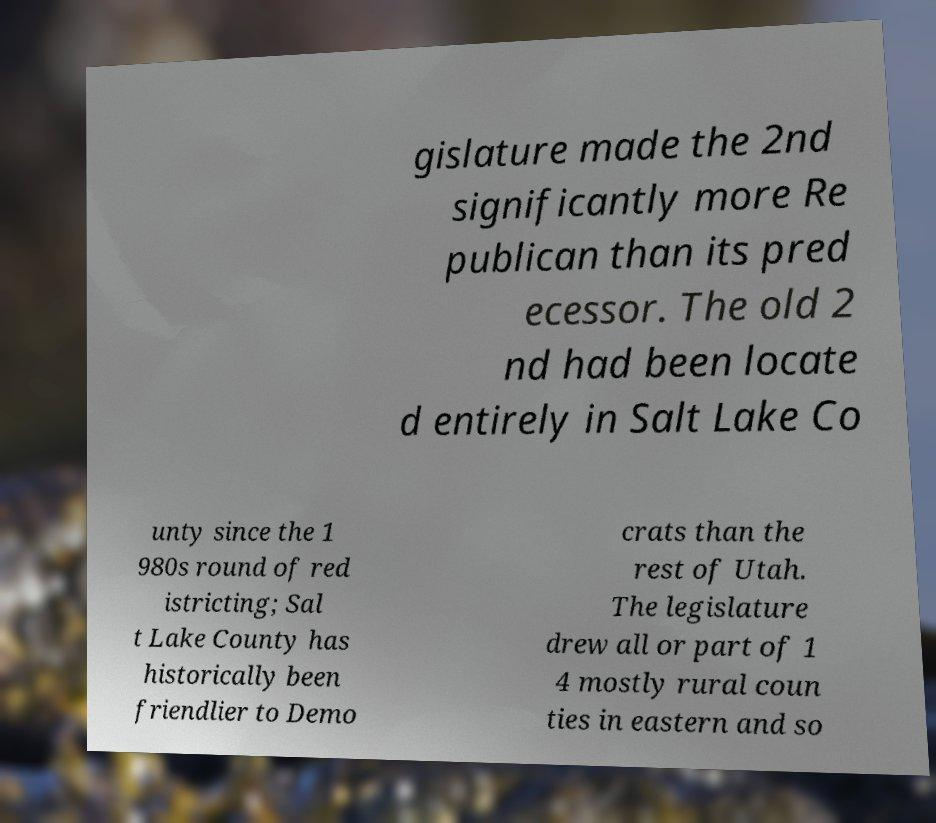Please read and relay the text visible in this image. What does it say? gislature made the 2nd significantly more Re publican than its pred ecessor. The old 2 nd had been locate d entirely in Salt Lake Co unty since the 1 980s round of red istricting; Sal t Lake County has historically been friendlier to Demo crats than the rest of Utah. The legislature drew all or part of 1 4 mostly rural coun ties in eastern and so 